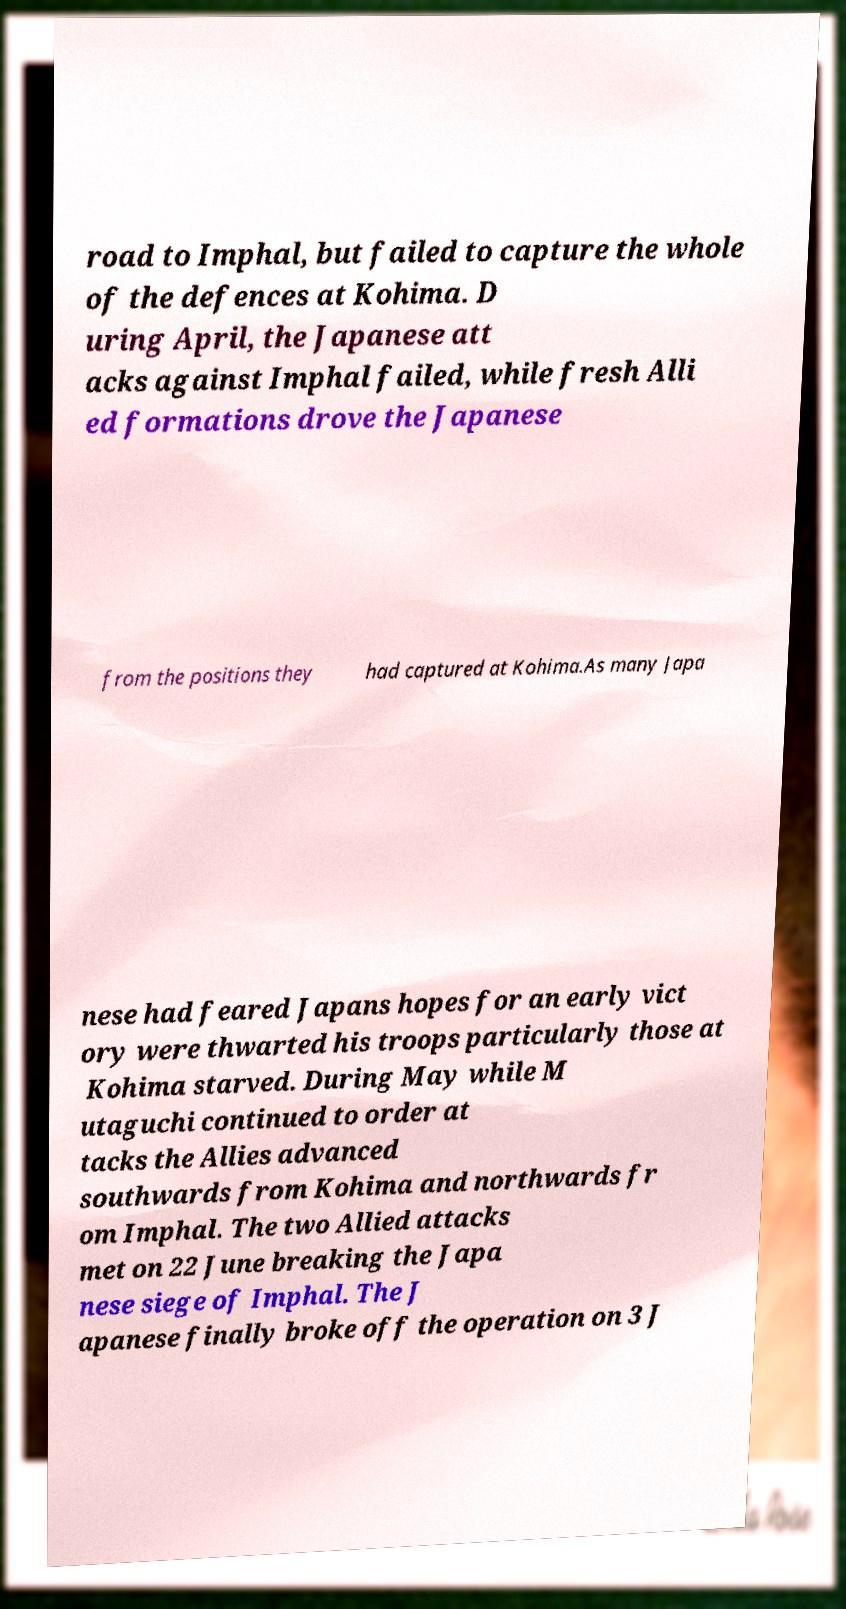For documentation purposes, I need the text within this image transcribed. Could you provide that? road to Imphal, but failed to capture the whole of the defences at Kohima. D uring April, the Japanese att acks against Imphal failed, while fresh Alli ed formations drove the Japanese from the positions they had captured at Kohima.As many Japa nese had feared Japans hopes for an early vict ory were thwarted his troops particularly those at Kohima starved. During May while M utaguchi continued to order at tacks the Allies advanced southwards from Kohima and northwards fr om Imphal. The two Allied attacks met on 22 June breaking the Japa nese siege of Imphal. The J apanese finally broke off the operation on 3 J 